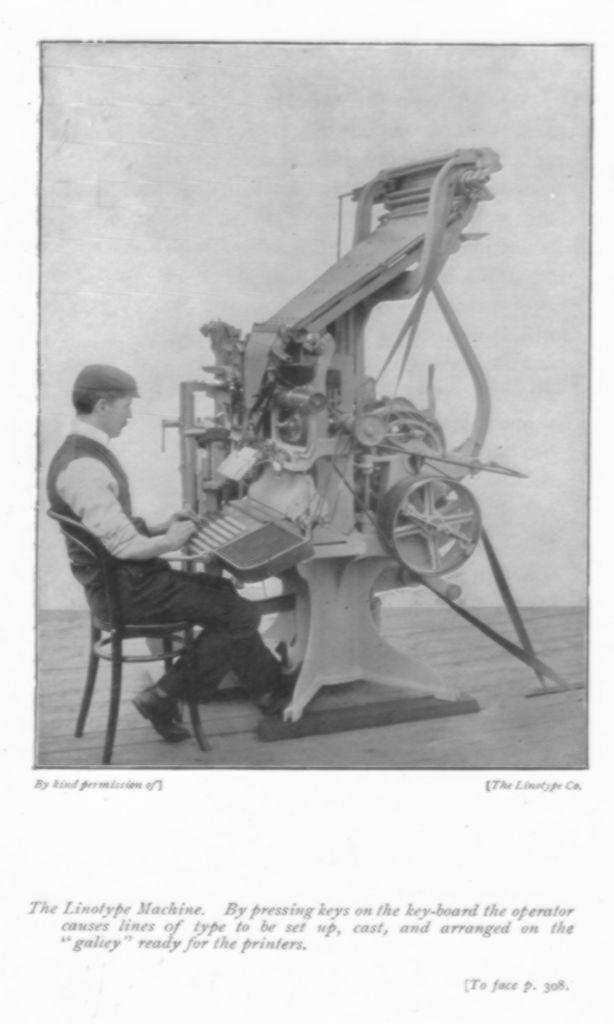Could you give a brief overview of what you see in this image? In this image I can see a person sitting on the chair. Front I can see a machine and keyboard. The image is in black and white. 